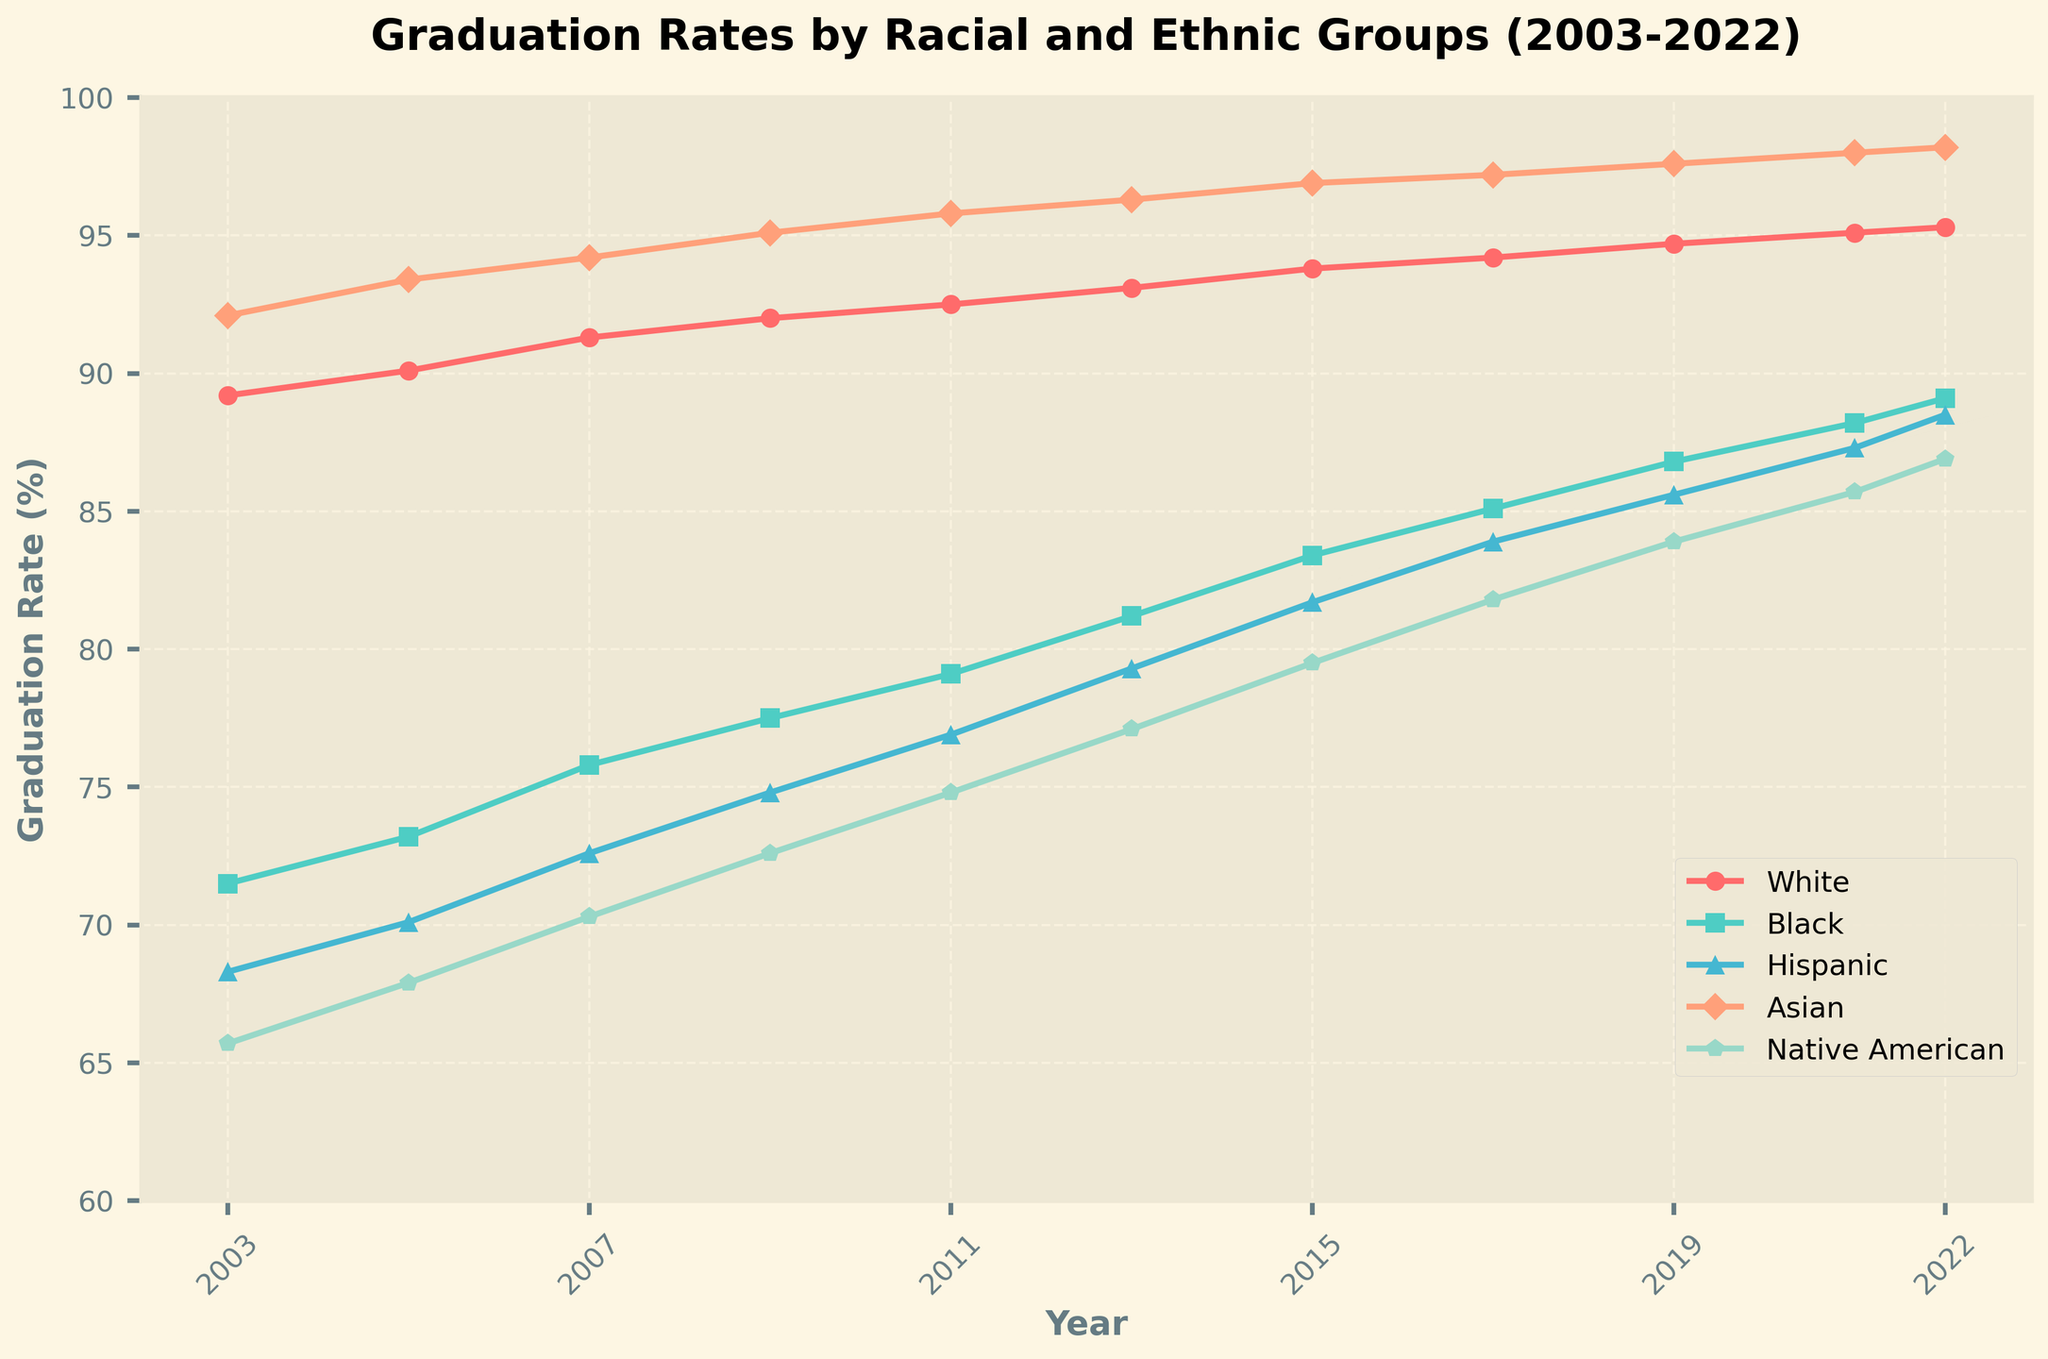What is the difference in graduation rates between Black and White students in 2003? Observing the plot's lines for Black and White students in 2003, Black students have a graduation rate of about 71.5%, while White students have about 89.2%. The difference is 89.2% - 71.5% = 17.7%.
Answer: 17.7% Which racial or ethnic group had the highest graduation rate in 2022? From the chart, the line for the Asian group is at the top in 2022, indicating Asians have the highest graduation rate.
Answer: Asian Between which years did Hispanic students show the most significant increase in graduation rates? By looking at the trendline for Hispanic students, the most significant increase appears between 2011 and 2013 where the rate jumps from 76.9% to 79.3%, a difference of 2.4 percentage points.
Answer: 2011-2013 What is the average graduation rate for Native American students over the 20 years? Adding the graduation rates for Native American students across all years: (65.7 + 67.9 + 70.3 + 72.6 + 74.8 + 77.1 + 79.5 + 81.8 + 83.9 + 85.7 + 86.9) and dividing by the number of data points (11) gives the average: 846.2 / 11 = 76.93%.
Answer: 76.93% By how much did the graduation rate for Asian students increase from 2003 to 2022? Asian students had a graduation rate of 92.1% in 2003 and 98.2% in 2022. The increase is 98.2% - 92.1% = 6.1%.
Answer: 6.1% Which racial or ethnic group showed the least improvement in graduation rates from 2003 to 2022? By comparing the starting and ending points for each group's lines, Native American students increased from 65.7% to 86.9%, which is an increase of 21.2 percentage points, the least among all the groups.
Answer: Native American Between 2005 and 2007, which group had the most significant improvement in graduation rates? By looking at the slopes of each line between 2005 and 2007, the Black line shows a rise from 73.2% to 75.8%, an increase of 2.6 percentage points, which is the most significant improvement during this period.
Answer: Black Which year did Hispanic students first cross an 80% graduation rate? Observing the graph, the Hispanic group first crosses the 80% graduation rate threshold in the year 2013.
Answer: 2013 